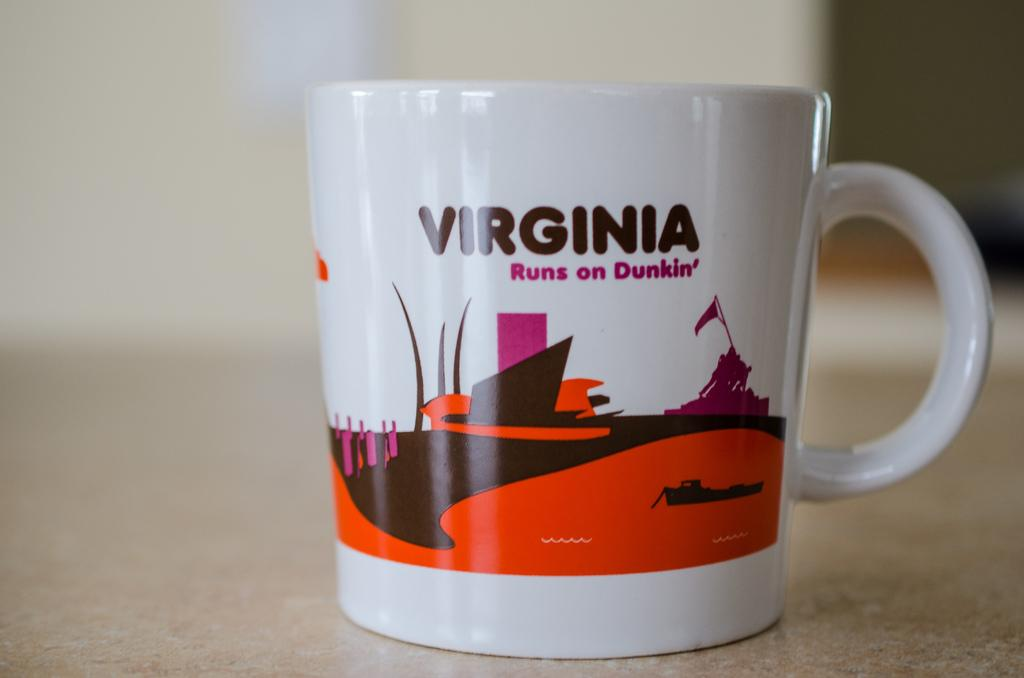What is the main object in the center of the image? There is a cup in the center of the image. Where is the cup located? The cup is placed on a surface. What can be seen in the background of the image? There is a wall in the background of the image. What type of vacation is depicted in the image? There is no vacation depicted in the image; it features a cup placed on a surface with a wall in the background. 